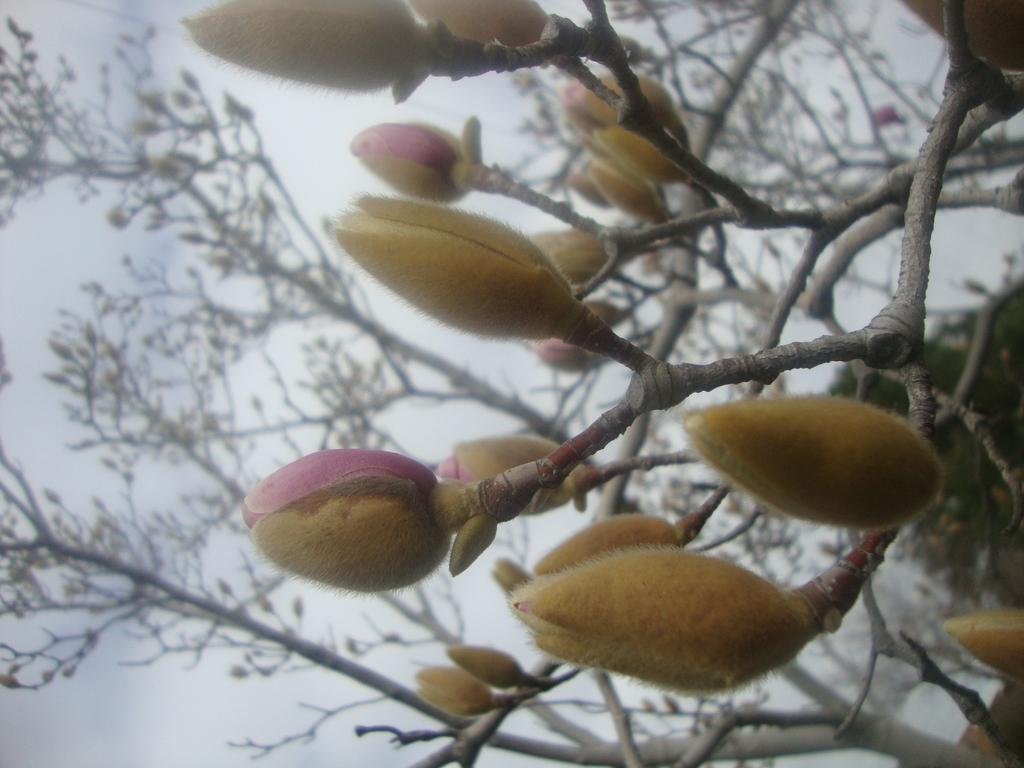What is growing on the plant in the image? There are flower buds on a plant in the image. What else can be seen in the image besides the plant with flower buds? There are other plants visible in the background of the image. What can be seen in the distance behind the plants? The sky is visible in the background of the image. What type of wine is being served at the gathering in the image? There is no gathering or wine present in the image; it features plants and the sky. What is the chance of rain in the image? The image does not provide any information about the weather or the chance of rain. 